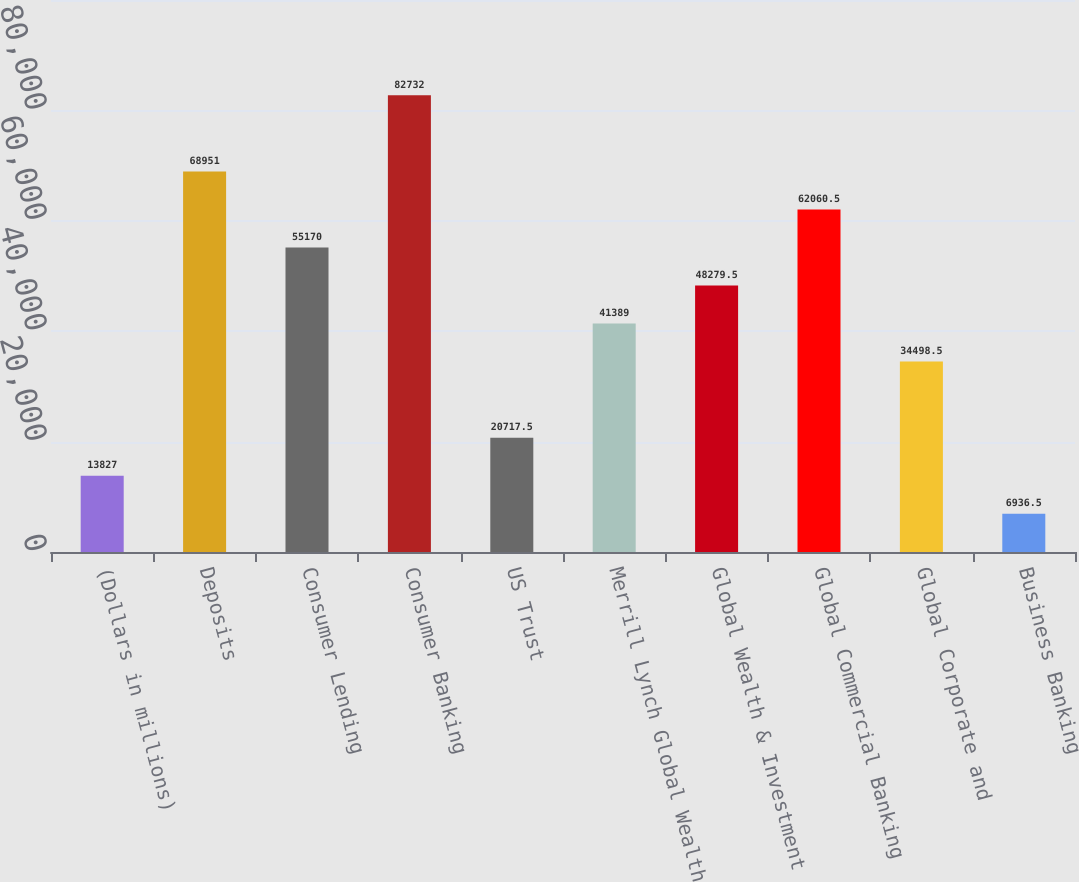<chart> <loc_0><loc_0><loc_500><loc_500><bar_chart><fcel>(Dollars in millions)<fcel>Deposits<fcel>Consumer Lending<fcel>Consumer Banking<fcel>US Trust<fcel>Merrill Lynch Global Wealth<fcel>Global Wealth & Investment<fcel>Global Commercial Banking<fcel>Global Corporate and<fcel>Business Banking<nl><fcel>13827<fcel>68951<fcel>55170<fcel>82732<fcel>20717.5<fcel>41389<fcel>48279.5<fcel>62060.5<fcel>34498.5<fcel>6936.5<nl></chart> 